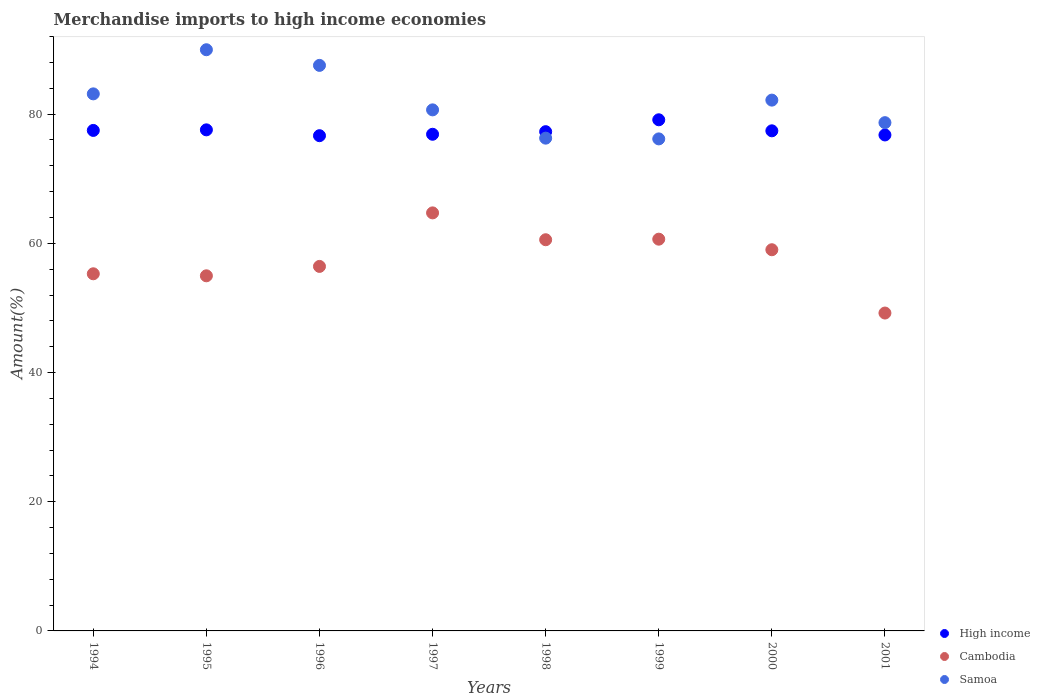How many different coloured dotlines are there?
Offer a terse response. 3. Is the number of dotlines equal to the number of legend labels?
Offer a terse response. Yes. What is the percentage of amount earned from merchandise imports in Cambodia in 1994?
Your answer should be compact. 55.28. Across all years, what is the maximum percentage of amount earned from merchandise imports in High income?
Offer a terse response. 79.12. Across all years, what is the minimum percentage of amount earned from merchandise imports in High income?
Your answer should be compact. 76.66. What is the total percentage of amount earned from merchandise imports in High income in the graph?
Provide a short and direct response. 619.19. What is the difference between the percentage of amount earned from merchandise imports in Samoa in 1994 and that in 1997?
Ensure brevity in your answer.  2.48. What is the difference between the percentage of amount earned from merchandise imports in High income in 1997 and the percentage of amount earned from merchandise imports in Cambodia in 1996?
Ensure brevity in your answer.  20.46. What is the average percentage of amount earned from merchandise imports in High income per year?
Ensure brevity in your answer.  77.4. In the year 1999, what is the difference between the percentage of amount earned from merchandise imports in High income and percentage of amount earned from merchandise imports in Cambodia?
Give a very brief answer. 18.48. In how many years, is the percentage of amount earned from merchandise imports in High income greater than 48 %?
Your answer should be compact. 8. What is the ratio of the percentage of amount earned from merchandise imports in Cambodia in 1995 to that in 1996?
Offer a terse response. 0.97. What is the difference between the highest and the second highest percentage of amount earned from merchandise imports in High income?
Offer a terse response. 1.56. What is the difference between the highest and the lowest percentage of amount earned from merchandise imports in Cambodia?
Your response must be concise. 15.5. Is the sum of the percentage of amount earned from merchandise imports in Cambodia in 1995 and 1999 greater than the maximum percentage of amount earned from merchandise imports in Samoa across all years?
Give a very brief answer. Yes. Is it the case that in every year, the sum of the percentage of amount earned from merchandise imports in Samoa and percentage of amount earned from merchandise imports in Cambodia  is greater than the percentage of amount earned from merchandise imports in High income?
Your answer should be very brief. Yes. What is the difference between two consecutive major ticks on the Y-axis?
Keep it short and to the point. 20. Does the graph contain any zero values?
Ensure brevity in your answer.  No. Does the graph contain grids?
Your answer should be very brief. No. How many legend labels are there?
Your answer should be very brief. 3. How are the legend labels stacked?
Provide a short and direct response. Vertical. What is the title of the graph?
Give a very brief answer. Merchandise imports to high income economies. What is the label or title of the X-axis?
Ensure brevity in your answer.  Years. What is the label or title of the Y-axis?
Give a very brief answer. Amount(%). What is the Amount(%) in High income in 1994?
Offer a terse response. 77.48. What is the Amount(%) of Cambodia in 1994?
Your response must be concise. 55.28. What is the Amount(%) in Samoa in 1994?
Offer a terse response. 83.14. What is the Amount(%) in High income in 1995?
Provide a short and direct response. 77.57. What is the Amount(%) of Cambodia in 1995?
Provide a short and direct response. 54.97. What is the Amount(%) of Samoa in 1995?
Ensure brevity in your answer.  89.97. What is the Amount(%) in High income in 1996?
Ensure brevity in your answer.  76.66. What is the Amount(%) in Cambodia in 1996?
Keep it short and to the point. 56.43. What is the Amount(%) in Samoa in 1996?
Your response must be concise. 87.55. What is the Amount(%) of High income in 1997?
Your answer should be compact. 76.88. What is the Amount(%) of Cambodia in 1997?
Offer a very short reply. 64.71. What is the Amount(%) in Samoa in 1997?
Ensure brevity in your answer.  80.66. What is the Amount(%) of High income in 1998?
Your response must be concise. 77.28. What is the Amount(%) of Cambodia in 1998?
Give a very brief answer. 60.55. What is the Amount(%) in Samoa in 1998?
Your answer should be very brief. 76.28. What is the Amount(%) of High income in 1999?
Offer a terse response. 79.12. What is the Amount(%) in Cambodia in 1999?
Your response must be concise. 60.64. What is the Amount(%) in Samoa in 1999?
Your answer should be compact. 76.17. What is the Amount(%) in High income in 2000?
Provide a short and direct response. 77.42. What is the Amount(%) in Cambodia in 2000?
Your answer should be very brief. 59.01. What is the Amount(%) in Samoa in 2000?
Offer a very short reply. 82.17. What is the Amount(%) of High income in 2001?
Ensure brevity in your answer.  76.78. What is the Amount(%) of Cambodia in 2001?
Give a very brief answer. 49.21. What is the Amount(%) in Samoa in 2001?
Provide a succinct answer. 78.68. Across all years, what is the maximum Amount(%) of High income?
Provide a short and direct response. 79.12. Across all years, what is the maximum Amount(%) of Cambodia?
Your answer should be compact. 64.71. Across all years, what is the maximum Amount(%) of Samoa?
Give a very brief answer. 89.97. Across all years, what is the minimum Amount(%) in High income?
Offer a very short reply. 76.66. Across all years, what is the minimum Amount(%) of Cambodia?
Offer a terse response. 49.21. Across all years, what is the minimum Amount(%) of Samoa?
Your answer should be compact. 76.17. What is the total Amount(%) in High income in the graph?
Provide a short and direct response. 619.19. What is the total Amount(%) of Cambodia in the graph?
Ensure brevity in your answer.  460.81. What is the total Amount(%) of Samoa in the graph?
Your answer should be compact. 654.6. What is the difference between the Amount(%) in High income in 1994 and that in 1995?
Ensure brevity in your answer.  -0.09. What is the difference between the Amount(%) of Cambodia in 1994 and that in 1995?
Offer a very short reply. 0.31. What is the difference between the Amount(%) in Samoa in 1994 and that in 1995?
Offer a terse response. -6.83. What is the difference between the Amount(%) in High income in 1994 and that in 1996?
Ensure brevity in your answer.  0.81. What is the difference between the Amount(%) in Cambodia in 1994 and that in 1996?
Offer a terse response. -1.14. What is the difference between the Amount(%) of Samoa in 1994 and that in 1996?
Offer a terse response. -4.41. What is the difference between the Amount(%) of High income in 1994 and that in 1997?
Your answer should be compact. 0.59. What is the difference between the Amount(%) in Cambodia in 1994 and that in 1997?
Give a very brief answer. -9.43. What is the difference between the Amount(%) of Samoa in 1994 and that in 1997?
Offer a terse response. 2.48. What is the difference between the Amount(%) in High income in 1994 and that in 1998?
Your answer should be very brief. 0.19. What is the difference between the Amount(%) in Cambodia in 1994 and that in 1998?
Give a very brief answer. -5.27. What is the difference between the Amount(%) in Samoa in 1994 and that in 1998?
Provide a short and direct response. 6.86. What is the difference between the Amount(%) of High income in 1994 and that in 1999?
Offer a terse response. -1.65. What is the difference between the Amount(%) in Cambodia in 1994 and that in 1999?
Offer a very short reply. -5.36. What is the difference between the Amount(%) in Samoa in 1994 and that in 1999?
Offer a terse response. 6.97. What is the difference between the Amount(%) of High income in 1994 and that in 2000?
Keep it short and to the point. 0.06. What is the difference between the Amount(%) in Cambodia in 1994 and that in 2000?
Your answer should be compact. -3.72. What is the difference between the Amount(%) of Samoa in 1994 and that in 2000?
Ensure brevity in your answer.  0.97. What is the difference between the Amount(%) in High income in 1994 and that in 2001?
Ensure brevity in your answer.  0.7. What is the difference between the Amount(%) in Cambodia in 1994 and that in 2001?
Give a very brief answer. 6.08. What is the difference between the Amount(%) in Samoa in 1994 and that in 2001?
Offer a terse response. 4.46. What is the difference between the Amount(%) in High income in 1995 and that in 1996?
Ensure brevity in your answer.  0.9. What is the difference between the Amount(%) in Cambodia in 1995 and that in 1996?
Offer a terse response. -1.45. What is the difference between the Amount(%) in Samoa in 1995 and that in 1996?
Make the answer very short. 2.42. What is the difference between the Amount(%) of High income in 1995 and that in 1997?
Make the answer very short. 0.68. What is the difference between the Amount(%) in Cambodia in 1995 and that in 1997?
Provide a succinct answer. -9.74. What is the difference between the Amount(%) of Samoa in 1995 and that in 1997?
Provide a succinct answer. 9.31. What is the difference between the Amount(%) of High income in 1995 and that in 1998?
Ensure brevity in your answer.  0.28. What is the difference between the Amount(%) of Cambodia in 1995 and that in 1998?
Provide a short and direct response. -5.58. What is the difference between the Amount(%) of Samoa in 1995 and that in 1998?
Offer a terse response. 13.69. What is the difference between the Amount(%) in High income in 1995 and that in 1999?
Make the answer very short. -1.56. What is the difference between the Amount(%) of Cambodia in 1995 and that in 1999?
Your answer should be very brief. -5.67. What is the difference between the Amount(%) in Samoa in 1995 and that in 1999?
Keep it short and to the point. 13.8. What is the difference between the Amount(%) in High income in 1995 and that in 2000?
Make the answer very short. 0.15. What is the difference between the Amount(%) in Cambodia in 1995 and that in 2000?
Your answer should be compact. -4.04. What is the difference between the Amount(%) of Samoa in 1995 and that in 2000?
Keep it short and to the point. 7.8. What is the difference between the Amount(%) of High income in 1995 and that in 2001?
Give a very brief answer. 0.79. What is the difference between the Amount(%) in Cambodia in 1995 and that in 2001?
Offer a very short reply. 5.76. What is the difference between the Amount(%) in Samoa in 1995 and that in 2001?
Your answer should be compact. 11.29. What is the difference between the Amount(%) in High income in 1996 and that in 1997?
Provide a succinct answer. -0.22. What is the difference between the Amount(%) of Cambodia in 1996 and that in 1997?
Make the answer very short. -8.29. What is the difference between the Amount(%) in Samoa in 1996 and that in 1997?
Your response must be concise. 6.89. What is the difference between the Amount(%) of High income in 1996 and that in 1998?
Offer a very short reply. -0.62. What is the difference between the Amount(%) of Cambodia in 1996 and that in 1998?
Your answer should be very brief. -4.13. What is the difference between the Amount(%) in Samoa in 1996 and that in 1998?
Give a very brief answer. 11.27. What is the difference between the Amount(%) in High income in 1996 and that in 1999?
Provide a succinct answer. -2.46. What is the difference between the Amount(%) in Cambodia in 1996 and that in 1999?
Provide a succinct answer. -4.22. What is the difference between the Amount(%) in Samoa in 1996 and that in 1999?
Your answer should be very brief. 11.38. What is the difference between the Amount(%) in High income in 1996 and that in 2000?
Ensure brevity in your answer.  -0.75. What is the difference between the Amount(%) of Cambodia in 1996 and that in 2000?
Provide a succinct answer. -2.58. What is the difference between the Amount(%) of Samoa in 1996 and that in 2000?
Ensure brevity in your answer.  5.38. What is the difference between the Amount(%) of High income in 1996 and that in 2001?
Make the answer very short. -0.11. What is the difference between the Amount(%) of Cambodia in 1996 and that in 2001?
Provide a short and direct response. 7.22. What is the difference between the Amount(%) in Samoa in 1996 and that in 2001?
Keep it short and to the point. 8.87. What is the difference between the Amount(%) in High income in 1997 and that in 1998?
Ensure brevity in your answer.  -0.4. What is the difference between the Amount(%) of Cambodia in 1997 and that in 1998?
Your response must be concise. 4.16. What is the difference between the Amount(%) of Samoa in 1997 and that in 1998?
Your answer should be very brief. 4.38. What is the difference between the Amount(%) in High income in 1997 and that in 1999?
Ensure brevity in your answer.  -2.24. What is the difference between the Amount(%) of Cambodia in 1997 and that in 1999?
Keep it short and to the point. 4.07. What is the difference between the Amount(%) in Samoa in 1997 and that in 1999?
Offer a terse response. 4.49. What is the difference between the Amount(%) of High income in 1997 and that in 2000?
Your answer should be very brief. -0.53. What is the difference between the Amount(%) in Cambodia in 1997 and that in 2000?
Your response must be concise. 5.7. What is the difference between the Amount(%) of Samoa in 1997 and that in 2000?
Provide a succinct answer. -1.51. What is the difference between the Amount(%) in High income in 1997 and that in 2001?
Give a very brief answer. 0.11. What is the difference between the Amount(%) in Cambodia in 1997 and that in 2001?
Ensure brevity in your answer.  15.5. What is the difference between the Amount(%) of Samoa in 1997 and that in 2001?
Ensure brevity in your answer.  1.98. What is the difference between the Amount(%) in High income in 1998 and that in 1999?
Offer a very short reply. -1.84. What is the difference between the Amount(%) in Cambodia in 1998 and that in 1999?
Keep it short and to the point. -0.09. What is the difference between the Amount(%) of Samoa in 1998 and that in 1999?
Offer a very short reply. 0.11. What is the difference between the Amount(%) of High income in 1998 and that in 2000?
Your response must be concise. -0.13. What is the difference between the Amount(%) in Cambodia in 1998 and that in 2000?
Make the answer very short. 1.55. What is the difference between the Amount(%) of Samoa in 1998 and that in 2000?
Your answer should be compact. -5.89. What is the difference between the Amount(%) in High income in 1998 and that in 2001?
Ensure brevity in your answer.  0.51. What is the difference between the Amount(%) in Cambodia in 1998 and that in 2001?
Give a very brief answer. 11.35. What is the difference between the Amount(%) in Samoa in 1998 and that in 2001?
Make the answer very short. -2.4. What is the difference between the Amount(%) of High income in 1999 and that in 2000?
Provide a succinct answer. 1.71. What is the difference between the Amount(%) of Cambodia in 1999 and that in 2000?
Offer a very short reply. 1.64. What is the difference between the Amount(%) in Samoa in 1999 and that in 2000?
Ensure brevity in your answer.  -6. What is the difference between the Amount(%) in High income in 1999 and that in 2001?
Make the answer very short. 2.35. What is the difference between the Amount(%) of Cambodia in 1999 and that in 2001?
Offer a very short reply. 11.44. What is the difference between the Amount(%) in Samoa in 1999 and that in 2001?
Ensure brevity in your answer.  -2.51. What is the difference between the Amount(%) of High income in 2000 and that in 2001?
Make the answer very short. 0.64. What is the difference between the Amount(%) of Cambodia in 2000 and that in 2001?
Make the answer very short. 9.8. What is the difference between the Amount(%) of Samoa in 2000 and that in 2001?
Keep it short and to the point. 3.49. What is the difference between the Amount(%) in High income in 1994 and the Amount(%) in Cambodia in 1995?
Your answer should be very brief. 22.51. What is the difference between the Amount(%) in High income in 1994 and the Amount(%) in Samoa in 1995?
Give a very brief answer. -12.49. What is the difference between the Amount(%) in Cambodia in 1994 and the Amount(%) in Samoa in 1995?
Offer a terse response. -34.68. What is the difference between the Amount(%) of High income in 1994 and the Amount(%) of Cambodia in 1996?
Provide a succinct answer. 21.05. What is the difference between the Amount(%) in High income in 1994 and the Amount(%) in Samoa in 1996?
Your answer should be compact. -10.07. What is the difference between the Amount(%) in Cambodia in 1994 and the Amount(%) in Samoa in 1996?
Your response must be concise. -32.26. What is the difference between the Amount(%) of High income in 1994 and the Amount(%) of Cambodia in 1997?
Your answer should be compact. 12.76. What is the difference between the Amount(%) in High income in 1994 and the Amount(%) in Samoa in 1997?
Your response must be concise. -3.18. What is the difference between the Amount(%) of Cambodia in 1994 and the Amount(%) of Samoa in 1997?
Keep it short and to the point. -25.38. What is the difference between the Amount(%) in High income in 1994 and the Amount(%) in Cambodia in 1998?
Keep it short and to the point. 16.92. What is the difference between the Amount(%) of High income in 1994 and the Amount(%) of Samoa in 1998?
Ensure brevity in your answer.  1.2. What is the difference between the Amount(%) of Cambodia in 1994 and the Amount(%) of Samoa in 1998?
Make the answer very short. -21. What is the difference between the Amount(%) in High income in 1994 and the Amount(%) in Cambodia in 1999?
Offer a very short reply. 16.83. What is the difference between the Amount(%) of High income in 1994 and the Amount(%) of Samoa in 1999?
Offer a very short reply. 1.31. What is the difference between the Amount(%) in Cambodia in 1994 and the Amount(%) in Samoa in 1999?
Provide a short and direct response. -20.88. What is the difference between the Amount(%) in High income in 1994 and the Amount(%) in Cambodia in 2000?
Give a very brief answer. 18.47. What is the difference between the Amount(%) in High income in 1994 and the Amount(%) in Samoa in 2000?
Your answer should be compact. -4.69. What is the difference between the Amount(%) of Cambodia in 1994 and the Amount(%) of Samoa in 2000?
Provide a short and direct response. -26.88. What is the difference between the Amount(%) in High income in 1994 and the Amount(%) in Cambodia in 2001?
Give a very brief answer. 28.27. What is the difference between the Amount(%) of High income in 1994 and the Amount(%) of Samoa in 2001?
Ensure brevity in your answer.  -1.2. What is the difference between the Amount(%) in Cambodia in 1994 and the Amount(%) in Samoa in 2001?
Offer a terse response. -23.4. What is the difference between the Amount(%) in High income in 1995 and the Amount(%) in Cambodia in 1996?
Ensure brevity in your answer.  21.14. What is the difference between the Amount(%) of High income in 1995 and the Amount(%) of Samoa in 1996?
Provide a short and direct response. -9.98. What is the difference between the Amount(%) in Cambodia in 1995 and the Amount(%) in Samoa in 1996?
Give a very brief answer. -32.57. What is the difference between the Amount(%) in High income in 1995 and the Amount(%) in Cambodia in 1997?
Keep it short and to the point. 12.85. What is the difference between the Amount(%) of High income in 1995 and the Amount(%) of Samoa in 1997?
Your answer should be compact. -3.09. What is the difference between the Amount(%) of Cambodia in 1995 and the Amount(%) of Samoa in 1997?
Your answer should be compact. -25.69. What is the difference between the Amount(%) of High income in 1995 and the Amount(%) of Cambodia in 1998?
Make the answer very short. 17.01. What is the difference between the Amount(%) in High income in 1995 and the Amount(%) in Samoa in 1998?
Provide a short and direct response. 1.29. What is the difference between the Amount(%) of Cambodia in 1995 and the Amount(%) of Samoa in 1998?
Your answer should be compact. -21.31. What is the difference between the Amount(%) of High income in 1995 and the Amount(%) of Cambodia in 1999?
Ensure brevity in your answer.  16.92. What is the difference between the Amount(%) in High income in 1995 and the Amount(%) in Samoa in 1999?
Offer a very short reply. 1.4. What is the difference between the Amount(%) of Cambodia in 1995 and the Amount(%) of Samoa in 1999?
Keep it short and to the point. -21.19. What is the difference between the Amount(%) of High income in 1995 and the Amount(%) of Cambodia in 2000?
Provide a short and direct response. 18.56. What is the difference between the Amount(%) of High income in 1995 and the Amount(%) of Samoa in 2000?
Give a very brief answer. -4.6. What is the difference between the Amount(%) in Cambodia in 1995 and the Amount(%) in Samoa in 2000?
Give a very brief answer. -27.2. What is the difference between the Amount(%) of High income in 1995 and the Amount(%) of Cambodia in 2001?
Provide a short and direct response. 28.36. What is the difference between the Amount(%) in High income in 1995 and the Amount(%) in Samoa in 2001?
Make the answer very short. -1.11. What is the difference between the Amount(%) in Cambodia in 1995 and the Amount(%) in Samoa in 2001?
Your response must be concise. -23.71. What is the difference between the Amount(%) of High income in 1996 and the Amount(%) of Cambodia in 1997?
Provide a short and direct response. 11.95. What is the difference between the Amount(%) in High income in 1996 and the Amount(%) in Samoa in 1997?
Ensure brevity in your answer.  -4. What is the difference between the Amount(%) of Cambodia in 1996 and the Amount(%) of Samoa in 1997?
Provide a short and direct response. -24.23. What is the difference between the Amount(%) of High income in 1996 and the Amount(%) of Cambodia in 1998?
Give a very brief answer. 16.11. What is the difference between the Amount(%) in High income in 1996 and the Amount(%) in Samoa in 1998?
Offer a terse response. 0.38. What is the difference between the Amount(%) of Cambodia in 1996 and the Amount(%) of Samoa in 1998?
Provide a short and direct response. -19.85. What is the difference between the Amount(%) in High income in 1996 and the Amount(%) in Cambodia in 1999?
Provide a succinct answer. 16.02. What is the difference between the Amount(%) in High income in 1996 and the Amount(%) in Samoa in 1999?
Provide a succinct answer. 0.5. What is the difference between the Amount(%) in Cambodia in 1996 and the Amount(%) in Samoa in 1999?
Your answer should be compact. -19.74. What is the difference between the Amount(%) of High income in 1996 and the Amount(%) of Cambodia in 2000?
Provide a succinct answer. 17.65. What is the difference between the Amount(%) of High income in 1996 and the Amount(%) of Samoa in 2000?
Ensure brevity in your answer.  -5.51. What is the difference between the Amount(%) in Cambodia in 1996 and the Amount(%) in Samoa in 2000?
Make the answer very short. -25.74. What is the difference between the Amount(%) in High income in 1996 and the Amount(%) in Cambodia in 2001?
Make the answer very short. 27.46. What is the difference between the Amount(%) in High income in 1996 and the Amount(%) in Samoa in 2001?
Give a very brief answer. -2.02. What is the difference between the Amount(%) in Cambodia in 1996 and the Amount(%) in Samoa in 2001?
Ensure brevity in your answer.  -22.25. What is the difference between the Amount(%) of High income in 1997 and the Amount(%) of Cambodia in 1998?
Keep it short and to the point. 16.33. What is the difference between the Amount(%) of High income in 1997 and the Amount(%) of Samoa in 1998?
Make the answer very short. 0.6. What is the difference between the Amount(%) of Cambodia in 1997 and the Amount(%) of Samoa in 1998?
Keep it short and to the point. -11.57. What is the difference between the Amount(%) in High income in 1997 and the Amount(%) in Cambodia in 1999?
Offer a very short reply. 16.24. What is the difference between the Amount(%) of High income in 1997 and the Amount(%) of Samoa in 1999?
Ensure brevity in your answer.  0.72. What is the difference between the Amount(%) in Cambodia in 1997 and the Amount(%) in Samoa in 1999?
Provide a short and direct response. -11.45. What is the difference between the Amount(%) in High income in 1997 and the Amount(%) in Cambodia in 2000?
Provide a short and direct response. 17.87. What is the difference between the Amount(%) in High income in 1997 and the Amount(%) in Samoa in 2000?
Make the answer very short. -5.29. What is the difference between the Amount(%) in Cambodia in 1997 and the Amount(%) in Samoa in 2000?
Offer a very short reply. -17.46. What is the difference between the Amount(%) of High income in 1997 and the Amount(%) of Cambodia in 2001?
Offer a very short reply. 27.68. What is the difference between the Amount(%) in High income in 1997 and the Amount(%) in Samoa in 2001?
Your response must be concise. -1.8. What is the difference between the Amount(%) in Cambodia in 1997 and the Amount(%) in Samoa in 2001?
Your answer should be compact. -13.97. What is the difference between the Amount(%) of High income in 1998 and the Amount(%) of Cambodia in 1999?
Offer a very short reply. 16.64. What is the difference between the Amount(%) of High income in 1998 and the Amount(%) of Samoa in 1999?
Make the answer very short. 1.12. What is the difference between the Amount(%) in Cambodia in 1998 and the Amount(%) in Samoa in 1999?
Ensure brevity in your answer.  -15.61. What is the difference between the Amount(%) of High income in 1998 and the Amount(%) of Cambodia in 2000?
Ensure brevity in your answer.  18.28. What is the difference between the Amount(%) of High income in 1998 and the Amount(%) of Samoa in 2000?
Your response must be concise. -4.88. What is the difference between the Amount(%) of Cambodia in 1998 and the Amount(%) of Samoa in 2000?
Make the answer very short. -21.61. What is the difference between the Amount(%) of High income in 1998 and the Amount(%) of Cambodia in 2001?
Provide a succinct answer. 28.08. What is the difference between the Amount(%) in High income in 1998 and the Amount(%) in Samoa in 2001?
Your response must be concise. -1.4. What is the difference between the Amount(%) in Cambodia in 1998 and the Amount(%) in Samoa in 2001?
Provide a succinct answer. -18.12. What is the difference between the Amount(%) in High income in 1999 and the Amount(%) in Cambodia in 2000?
Ensure brevity in your answer.  20.12. What is the difference between the Amount(%) of High income in 1999 and the Amount(%) of Samoa in 2000?
Offer a terse response. -3.04. What is the difference between the Amount(%) in Cambodia in 1999 and the Amount(%) in Samoa in 2000?
Make the answer very short. -21.53. What is the difference between the Amount(%) of High income in 1999 and the Amount(%) of Cambodia in 2001?
Your answer should be very brief. 29.92. What is the difference between the Amount(%) in High income in 1999 and the Amount(%) in Samoa in 2001?
Your response must be concise. 0.45. What is the difference between the Amount(%) in Cambodia in 1999 and the Amount(%) in Samoa in 2001?
Your answer should be compact. -18.04. What is the difference between the Amount(%) of High income in 2000 and the Amount(%) of Cambodia in 2001?
Ensure brevity in your answer.  28.21. What is the difference between the Amount(%) in High income in 2000 and the Amount(%) in Samoa in 2001?
Offer a very short reply. -1.26. What is the difference between the Amount(%) in Cambodia in 2000 and the Amount(%) in Samoa in 2001?
Give a very brief answer. -19.67. What is the average Amount(%) of High income per year?
Provide a succinct answer. 77.4. What is the average Amount(%) of Cambodia per year?
Offer a very short reply. 57.6. What is the average Amount(%) in Samoa per year?
Provide a short and direct response. 81.83. In the year 1994, what is the difference between the Amount(%) of High income and Amount(%) of Cambodia?
Your answer should be very brief. 22.19. In the year 1994, what is the difference between the Amount(%) of High income and Amount(%) of Samoa?
Your response must be concise. -5.66. In the year 1994, what is the difference between the Amount(%) in Cambodia and Amount(%) in Samoa?
Your answer should be very brief. -27.85. In the year 1995, what is the difference between the Amount(%) in High income and Amount(%) in Cambodia?
Give a very brief answer. 22.59. In the year 1995, what is the difference between the Amount(%) of High income and Amount(%) of Samoa?
Your answer should be very brief. -12.4. In the year 1995, what is the difference between the Amount(%) in Cambodia and Amount(%) in Samoa?
Provide a short and direct response. -35. In the year 1996, what is the difference between the Amount(%) in High income and Amount(%) in Cambodia?
Provide a short and direct response. 20.24. In the year 1996, what is the difference between the Amount(%) in High income and Amount(%) in Samoa?
Offer a very short reply. -10.88. In the year 1996, what is the difference between the Amount(%) of Cambodia and Amount(%) of Samoa?
Your answer should be very brief. -31.12. In the year 1997, what is the difference between the Amount(%) of High income and Amount(%) of Cambodia?
Your answer should be compact. 12.17. In the year 1997, what is the difference between the Amount(%) of High income and Amount(%) of Samoa?
Provide a succinct answer. -3.78. In the year 1997, what is the difference between the Amount(%) in Cambodia and Amount(%) in Samoa?
Your response must be concise. -15.95. In the year 1998, what is the difference between the Amount(%) in High income and Amount(%) in Cambodia?
Ensure brevity in your answer.  16.73. In the year 1998, what is the difference between the Amount(%) of High income and Amount(%) of Samoa?
Provide a short and direct response. 1. In the year 1998, what is the difference between the Amount(%) in Cambodia and Amount(%) in Samoa?
Your answer should be compact. -15.73. In the year 1999, what is the difference between the Amount(%) in High income and Amount(%) in Cambodia?
Your answer should be compact. 18.48. In the year 1999, what is the difference between the Amount(%) in High income and Amount(%) in Samoa?
Offer a very short reply. 2.96. In the year 1999, what is the difference between the Amount(%) of Cambodia and Amount(%) of Samoa?
Give a very brief answer. -15.52. In the year 2000, what is the difference between the Amount(%) of High income and Amount(%) of Cambodia?
Your response must be concise. 18.41. In the year 2000, what is the difference between the Amount(%) in High income and Amount(%) in Samoa?
Offer a very short reply. -4.75. In the year 2000, what is the difference between the Amount(%) in Cambodia and Amount(%) in Samoa?
Give a very brief answer. -23.16. In the year 2001, what is the difference between the Amount(%) in High income and Amount(%) in Cambodia?
Give a very brief answer. 27.57. In the year 2001, what is the difference between the Amount(%) of High income and Amount(%) of Samoa?
Make the answer very short. -1.9. In the year 2001, what is the difference between the Amount(%) of Cambodia and Amount(%) of Samoa?
Offer a terse response. -29.47. What is the ratio of the Amount(%) of High income in 1994 to that in 1995?
Ensure brevity in your answer.  1. What is the ratio of the Amount(%) of Cambodia in 1994 to that in 1995?
Provide a short and direct response. 1.01. What is the ratio of the Amount(%) in Samoa in 1994 to that in 1995?
Keep it short and to the point. 0.92. What is the ratio of the Amount(%) in High income in 1994 to that in 1996?
Give a very brief answer. 1.01. What is the ratio of the Amount(%) of Cambodia in 1994 to that in 1996?
Keep it short and to the point. 0.98. What is the ratio of the Amount(%) in Samoa in 1994 to that in 1996?
Your answer should be compact. 0.95. What is the ratio of the Amount(%) of High income in 1994 to that in 1997?
Make the answer very short. 1.01. What is the ratio of the Amount(%) in Cambodia in 1994 to that in 1997?
Provide a succinct answer. 0.85. What is the ratio of the Amount(%) of Samoa in 1994 to that in 1997?
Provide a short and direct response. 1.03. What is the ratio of the Amount(%) of Cambodia in 1994 to that in 1998?
Your answer should be very brief. 0.91. What is the ratio of the Amount(%) in Samoa in 1994 to that in 1998?
Your response must be concise. 1.09. What is the ratio of the Amount(%) of High income in 1994 to that in 1999?
Provide a short and direct response. 0.98. What is the ratio of the Amount(%) of Cambodia in 1994 to that in 1999?
Offer a terse response. 0.91. What is the ratio of the Amount(%) in Samoa in 1994 to that in 1999?
Make the answer very short. 1.09. What is the ratio of the Amount(%) in High income in 1994 to that in 2000?
Give a very brief answer. 1. What is the ratio of the Amount(%) in Cambodia in 1994 to that in 2000?
Offer a very short reply. 0.94. What is the ratio of the Amount(%) in Samoa in 1994 to that in 2000?
Ensure brevity in your answer.  1.01. What is the ratio of the Amount(%) in High income in 1994 to that in 2001?
Keep it short and to the point. 1.01. What is the ratio of the Amount(%) in Cambodia in 1994 to that in 2001?
Make the answer very short. 1.12. What is the ratio of the Amount(%) in Samoa in 1994 to that in 2001?
Make the answer very short. 1.06. What is the ratio of the Amount(%) of High income in 1995 to that in 1996?
Give a very brief answer. 1.01. What is the ratio of the Amount(%) of Cambodia in 1995 to that in 1996?
Ensure brevity in your answer.  0.97. What is the ratio of the Amount(%) of Samoa in 1995 to that in 1996?
Your response must be concise. 1.03. What is the ratio of the Amount(%) of High income in 1995 to that in 1997?
Offer a terse response. 1.01. What is the ratio of the Amount(%) in Cambodia in 1995 to that in 1997?
Provide a succinct answer. 0.85. What is the ratio of the Amount(%) of Samoa in 1995 to that in 1997?
Keep it short and to the point. 1.12. What is the ratio of the Amount(%) of High income in 1995 to that in 1998?
Offer a terse response. 1. What is the ratio of the Amount(%) in Cambodia in 1995 to that in 1998?
Your response must be concise. 0.91. What is the ratio of the Amount(%) in Samoa in 1995 to that in 1998?
Provide a succinct answer. 1.18. What is the ratio of the Amount(%) of High income in 1995 to that in 1999?
Your answer should be compact. 0.98. What is the ratio of the Amount(%) in Cambodia in 1995 to that in 1999?
Give a very brief answer. 0.91. What is the ratio of the Amount(%) in Samoa in 1995 to that in 1999?
Offer a very short reply. 1.18. What is the ratio of the Amount(%) in Cambodia in 1995 to that in 2000?
Provide a short and direct response. 0.93. What is the ratio of the Amount(%) in Samoa in 1995 to that in 2000?
Offer a very short reply. 1.09. What is the ratio of the Amount(%) of High income in 1995 to that in 2001?
Ensure brevity in your answer.  1.01. What is the ratio of the Amount(%) of Cambodia in 1995 to that in 2001?
Your answer should be very brief. 1.12. What is the ratio of the Amount(%) in Samoa in 1995 to that in 2001?
Keep it short and to the point. 1.14. What is the ratio of the Amount(%) in High income in 1996 to that in 1997?
Make the answer very short. 1. What is the ratio of the Amount(%) in Cambodia in 1996 to that in 1997?
Give a very brief answer. 0.87. What is the ratio of the Amount(%) in Samoa in 1996 to that in 1997?
Your answer should be very brief. 1.09. What is the ratio of the Amount(%) in Cambodia in 1996 to that in 1998?
Give a very brief answer. 0.93. What is the ratio of the Amount(%) of Samoa in 1996 to that in 1998?
Provide a short and direct response. 1.15. What is the ratio of the Amount(%) in High income in 1996 to that in 1999?
Provide a succinct answer. 0.97. What is the ratio of the Amount(%) in Cambodia in 1996 to that in 1999?
Keep it short and to the point. 0.93. What is the ratio of the Amount(%) in Samoa in 1996 to that in 1999?
Ensure brevity in your answer.  1.15. What is the ratio of the Amount(%) of High income in 1996 to that in 2000?
Make the answer very short. 0.99. What is the ratio of the Amount(%) in Cambodia in 1996 to that in 2000?
Give a very brief answer. 0.96. What is the ratio of the Amount(%) of Samoa in 1996 to that in 2000?
Keep it short and to the point. 1.07. What is the ratio of the Amount(%) in High income in 1996 to that in 2001?
Make the answer very short. 1. What is the ratio of the Amount(%) in Cambodia in 1996 to that in 2001?
Your answer should be compact. 1.15. What is the ratio of the Amount(%) of Samoa in 1996 to that in 2001?
Your response must be concise. 1.11. What is the ratio of the Amount(%) of Cambodia in 1997 to that in 1998?
Make the answer very short. 1.07. What is the ratio of the Amount(%) in Samoa in 1997 to that in 1998?
Provide a succinct answer. 1.06. What is the ratio of the Amount(%) in High income in 1997 to that in 1999?
Offer a terse response. 0.97. What is the ratio of the Amount(%) in Cambodia in 1997 to that in 1999?
Your response must be concise. 1.07. What is the ratio of the Amount(%) in Samoa in 1997 to that in 1999?
Give a very brief answer. 1.06. What is the ratio of the Amount(%) in Cambodia in 1997 to that in 2000?
Give a very brief answer. 1.1. What is the ratio of the Amount(%) in Samoa in 1997 to that in 2000?
Offer a very short reply. 0.98. What is the ratio of the Amount(%) in Cambodia in 1997 to that in 2001?
Your response must be concise. 1.32. What is the ratio of the Amount(%) in Samoa in 1997 to that in 2001?
Your response must be concise. 1.03. What is the ratio of the Amount(%) in High income in 1998 to that in 1999?
Your answer should be compact. 0.98. What is the ratio of the Amount(%) of Samoa in 1998 to that in 1999?
Your answer should be compact. 1. What is the ratio of the Amount(%) in High income in 1998 to that in 2000?
Provide a short and direct response. 1. What is the ratio of the Amount(%) in Cambodia in 1998 to that in 2000?
Ensure brevity in your answer.  1.03. What is the ratio of the Amount(%) of Samoa in 1998 to that in 2000?
Give a very brief answer. 0.93. What is the ratio of the Amount(%) of High income in 1998 to that in 2001?
Provide a succinct answer. 1.01. What is the ratio of the Amount(%) in Cambodia in 1998 to that in 2001?
Provide a short and direct response. 1.23. What is the ratio of the Amount(%) of Samoa in 1998 to that in 2001?
Provide a short and direct response. 0.97. What is the ratio of the Amount(%) in High income in 1999 to that in 2000?
Ensure brevity in your answer.  1.02. What is the ratio of the Amount(%) of Cambodia in 1999 to that in 2000?
Your answer should be very brief. 1.03. What is the ratio of the Amount(%) in Samoa in 1999 to that in 2000?
Offer a terse response. 0.93. What is the ratio of the Amount(%) of High income in 1999 to that in 2001?
Provide a succinct answer. 1.03. What is the ratio of the Amount(%) of Cambodia in 1999 to that in 2001?
Make the answer very short. 1.23. What is the ratio of the Amount(%) in Samoa in 1999 to that in 2001?
Your response must be concise. 0.97. What is the ratio of the Amount(%) in High income in 2000 to that in 2001?
Your response must be concise. 1.01. What is the ratio of the Amount(%) of Cambodia in 2000 to that in 2001?
Ensure brevity in your answer.  1.2. What is the ratio of the Amount(%) of Samoa in 2000 to that in 2001?
Ensure brevity in your answer.  1.04. What is the difference between the highest and the second highest Amount(%) of High income?
Offer a very short reply. 1.56. What is the difference between the highest and the second highest Amount(%) of Cambodia?
Your answer should be very brief. 4.07. What is the difference between the highest and the second highest Amount(%) in Samoa?
Give a very brief answer. 2.42. What is the difference between the highest and the lowest Amount(%) in High income?
Offer a terse response. 2.46. What is the difference between the highest and the lowest Amount(%) in Cambodia?
Offer a very short reply. 15.5. What is the difference between the highest and the lowest Amount(%) in Samoa?
Your answer should be compact. 13.8. 